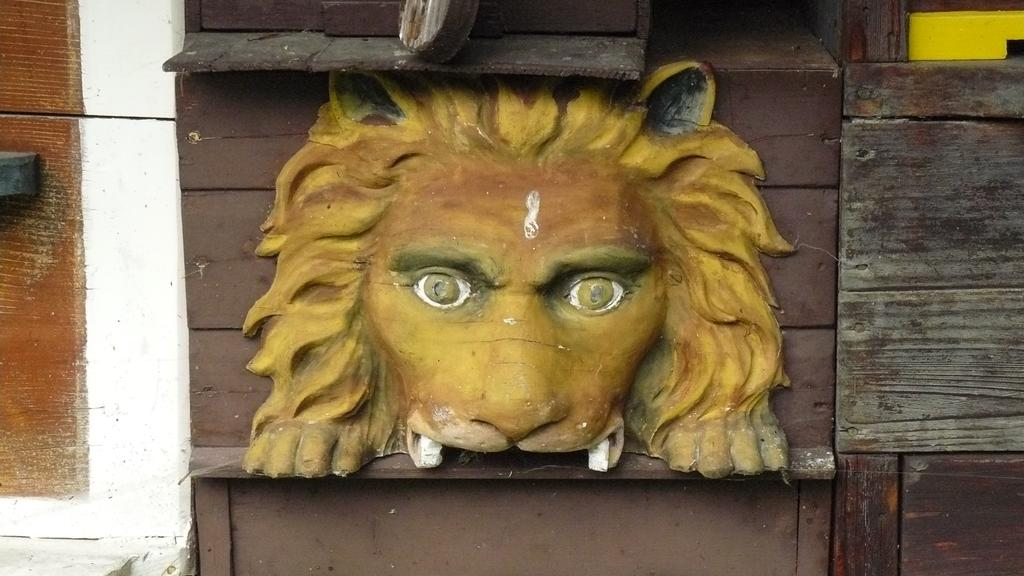What is the main subject of the image? The main subject of the image is a sculpture of an animal. Can you describe the material of the wall behind the sculpture? The sculpture is on a wooden wall. Where is the sculpture located in the image? The sculpture is in the middle of the image. How many drawers are visible in the image? There are no drawers present in the image. Is there any soap visible in the image? There is no soap present in the image. Can you see any airplanes or airport-related structures in the image? There are no airplanes or airport-related structures present in the image. 